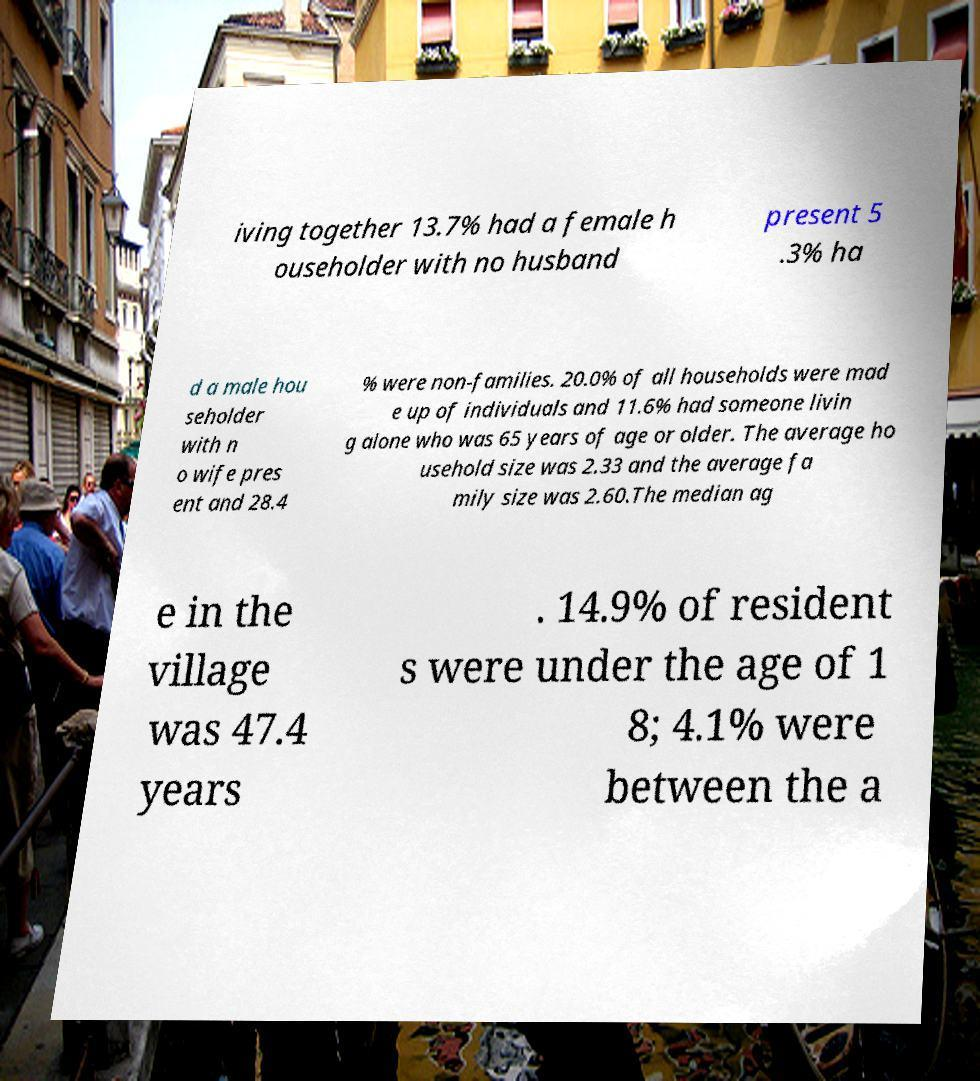Can you read and provide the text displayed in the image?This photo seems to have some interesting text. Can you extract and type it out for me? iving together 13.7% had a female h ouseholder with no husband present 5 .3% ha d a male hou seholder with n o wife pres ent and 28.4 % were non-families. 20.0% of all households were mad e up of individuals and 11.6% had someone livin g alone who was 65 years of age or older. The average ho usehold size was 2.33 and the average fa mily size was 2.60.The median ag e in the village was 47.4 years . 14.9% of resident s were under the age of 1 8; 4.1% were between the a 